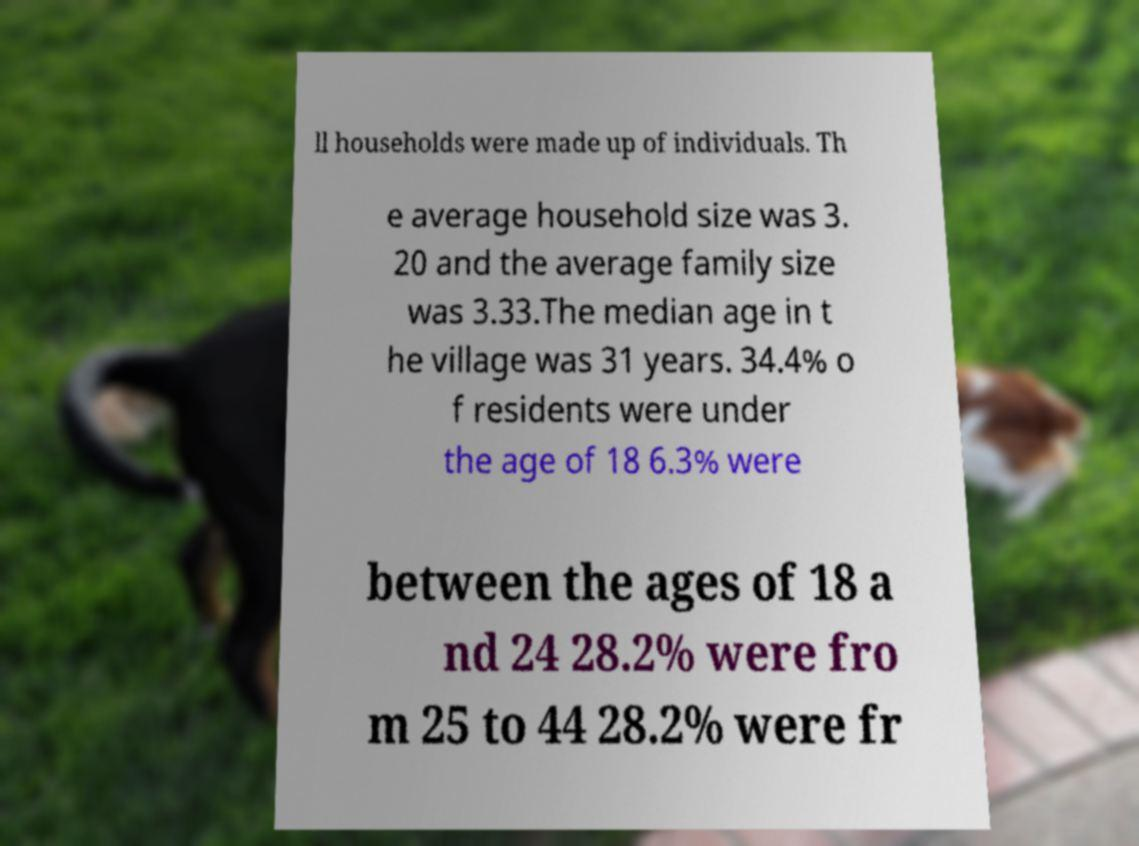For documentation purposes, I need the text within this image transcribed. Could you provide that? ll households were made up of individuals. Th e average household size was 3. 20 and the average family size was 3.33.The median age in t he village was 31 years. 34.4% o f residents were under the age of 18 6.3% were between the ages of 18 a nd 24 28.2% were fro m 25 to 44 28.2% were fr 